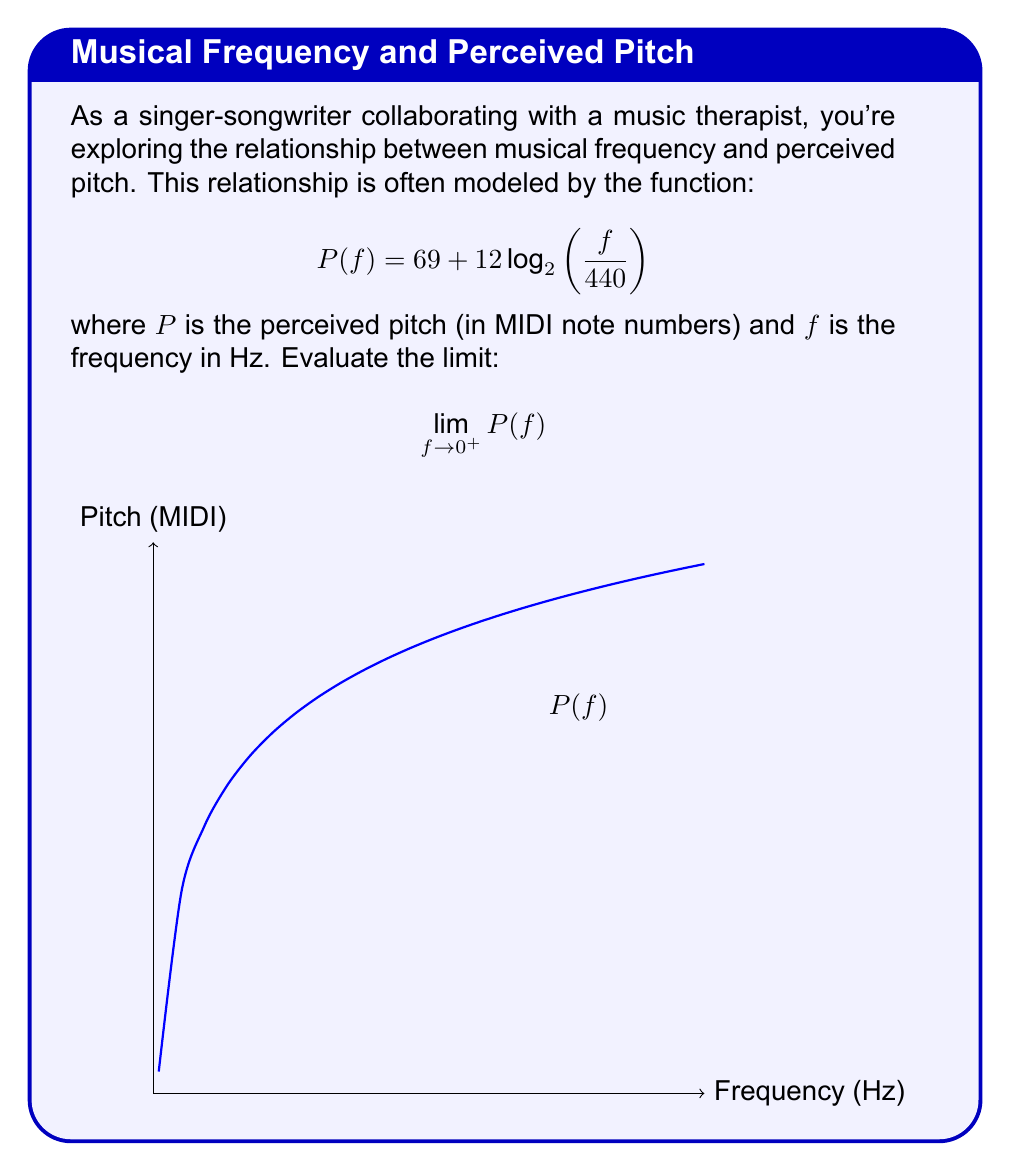Can you answer this question? Let's approach this step-by-step:

1) We start with the function:
   $$P(f) = 69 + 12 \log_2\left(\frac{f}{440}\right)$$

2) We need to evaluate the limit as $f$ approaches 0 from the right side:
   $$\lim_{f \to 0^+} \left(69 + 12 \log_2\left(\frac{f}{440}\right)\right)$$

3) We can separate this into two parts:
   $$\lim_{f \to 0^+} 69 + \lim_{f \to 0^+} 12 \log_2\left(\frac{f}{440}\right)$$

4) The first part is straightforward:
   $$\lim_{f \to 0^+} 69 = 69$$

5) For the second part, let's focus on the logarithm:
   $$\lim_{f \to 0^+} \log_2\left(\frac{f}{440}\right)$$

6) As $f$ approaches 0, $\frac{f}{440}$ also approaches 0. The logarithm of a number approaching 0 goes to negative infinity:
   $$\lim_{f \to 0^+} \log_2\left(\frac{f}{440}\right) = -\infty$$

7) Therefore:
   $$\lim_{f \to 0^+} 12 \log_2\left(\frac{f}{440}\right) = 12 \cdot (-\infty) = -\infty$$

8) Combining the results:
   $$\lim_{f \to 0^+} P(f) = 69 + (-\infty) = -\infty$$

Thus, as the frequency approaches 0, the perceived pitch goes to negative infinity.
Answer: $-\infty$ 